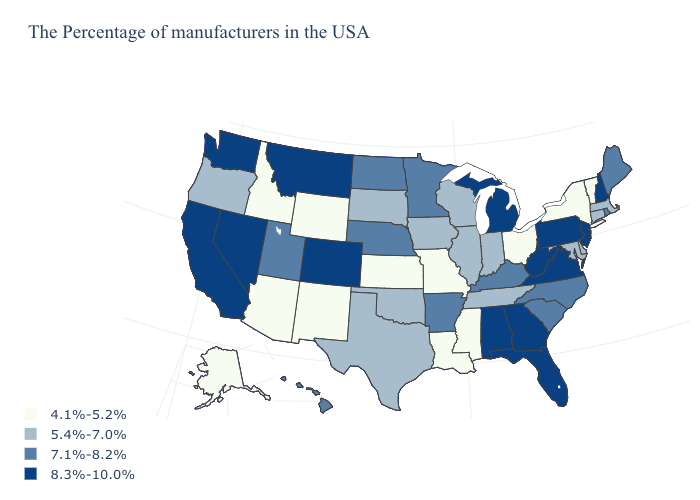Name the states that have a value in the range 5.4%-7.0%?
Concise answer only. Massachusetts, Connecticut, Delaware, Maryland, Indiana, Tennessee, Wisconsin, Illinois, Iowa, Oklahoma, Texas, South Dakota, Oregon. What is the value of Idaho?
Be succinct. 4.1%-5.2%. Among the states that border Colorado , which have the highest value?
Be succinct. Nebraska, Utah. Does Vermont have a higher value than Colorado?
Quick response, please. No. Does the map have missing data?
Answer briefly. No. Does Utah have the lowest value in the USA?
Give a very brief answer. No. Does New Hampshire have the lowest value in the USA?
Concise answer only. No. Name the states that have a value in the range 5.4%-7.0%?
Concise answer only. Massachusetts, Connecticut, Delaware, Maryland, Indiana, Tennessee, Wisconsin, Illinois, Iowa, Oklahoma, Texas, South Dakota, Oregon. Among the states that border Oregon , which have the lowest value?
Give a very brief answer. Idaho. Name the states that have a value in the range 7.1%-8.2%?
Write a very short answer. Maine, Rhode Island, North Carolina, South Carolina, Kentucky, Arkansas, Minnesota, Nebraska, North Dakota, Utah, Hawaii. What is the value of Idaho?
Be succinct. 4.1%-5.2%. Does Maryland have the highest value in the South?
Write a very short answer. No. Does the map have missing data?
Give a very brief answer. No. What is the lowest value in the MidWest?
Short answer required. 4.1%-5.2%. Does the map have missing data?
Short answer required. No. 